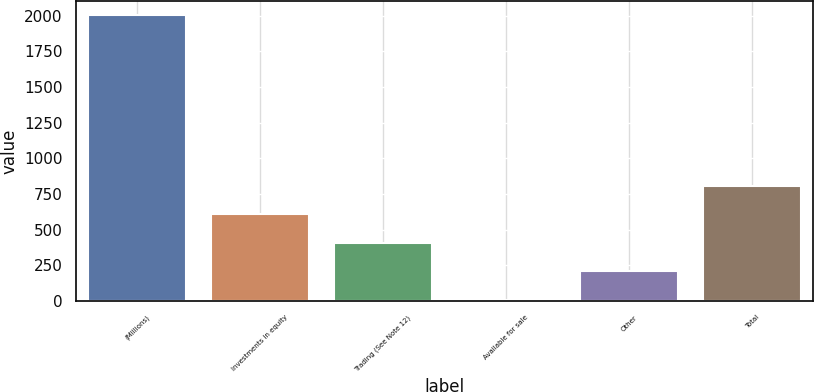Convert chart to OTSL. <chart><loc_0><loc_0><loc_500><loc_500><bar_chart><fcel>(Millions)<fcel>Investments in equity<fcel>Trading (See Note 12)<fcel>Available for sale<fcel>Other<fcel>Total<nl><fcel>2003<fcel>607.2<fcel>407.8<fcel>9<fcel>208.4<fcel>806.6<nl></chart> 